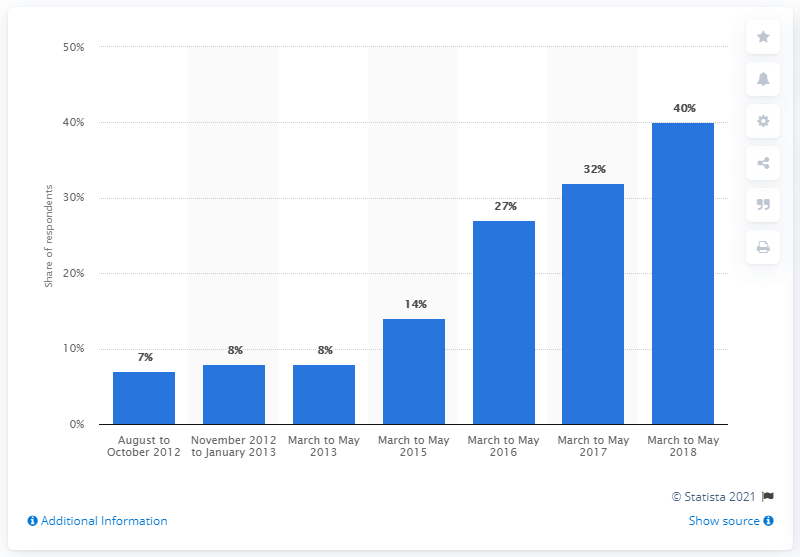Outline some significant characteristics in this image. Of the periods provided, how many have the same percentage? During the period of March to May 2018, 40% of the data points fell within this range. 